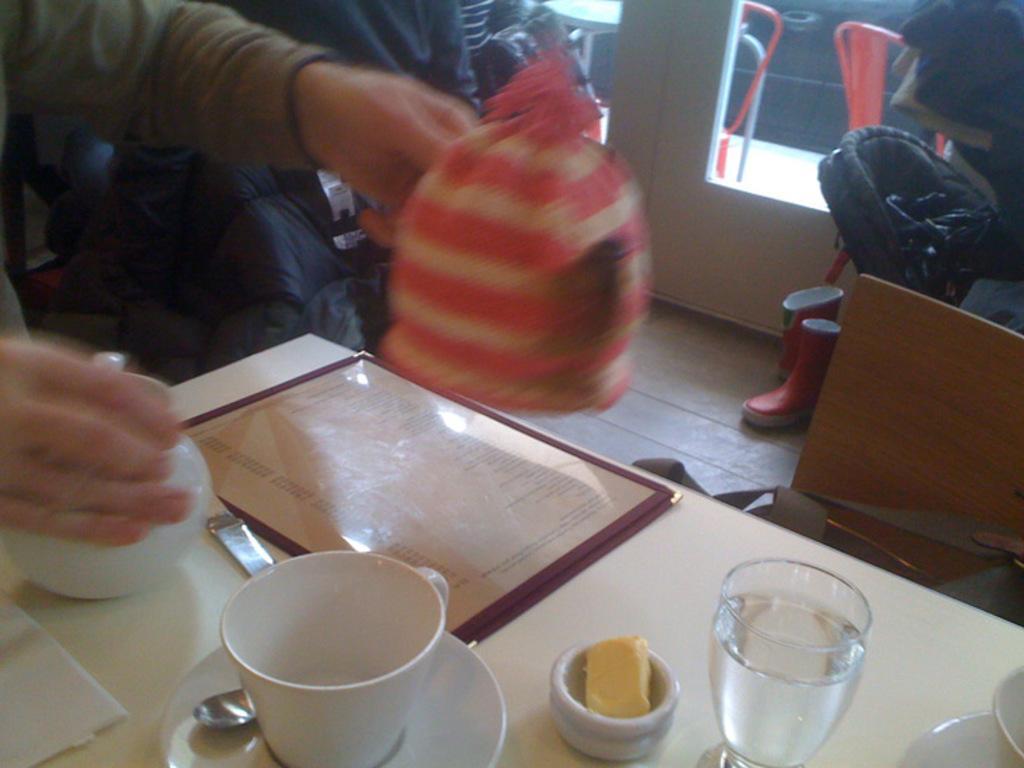Can you describe this image briefly? In this picture we can see table and on table we have cup, saucer, spoon, glass with water in it, tea pot and in the background we can see two persons, window, shoes, chairs. 